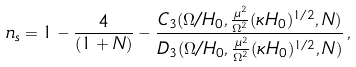<formula> <loc_0><loc_0><loc_500><loc_500>n _ { s } = 1 - \frac { 4 } { ( 1 + N ) } - \frac { C _ { 3 } ( \Omega / H _ { 0 } , \frac { \mu ^ { 2 } } { \Omega ^ { 2 } } ( \kappa H _ { 0 } ) ^ { 1 / 2 } , N ) } { D _ { 3 } ( \Omega / H _ { 0 } , \frac { \mu ^ { 2 } } { \Omega ^ { 2 } } ( \kappa H _ { 0 } ) ^ { 1 / 2 } , N ) } \, ,</formula> 